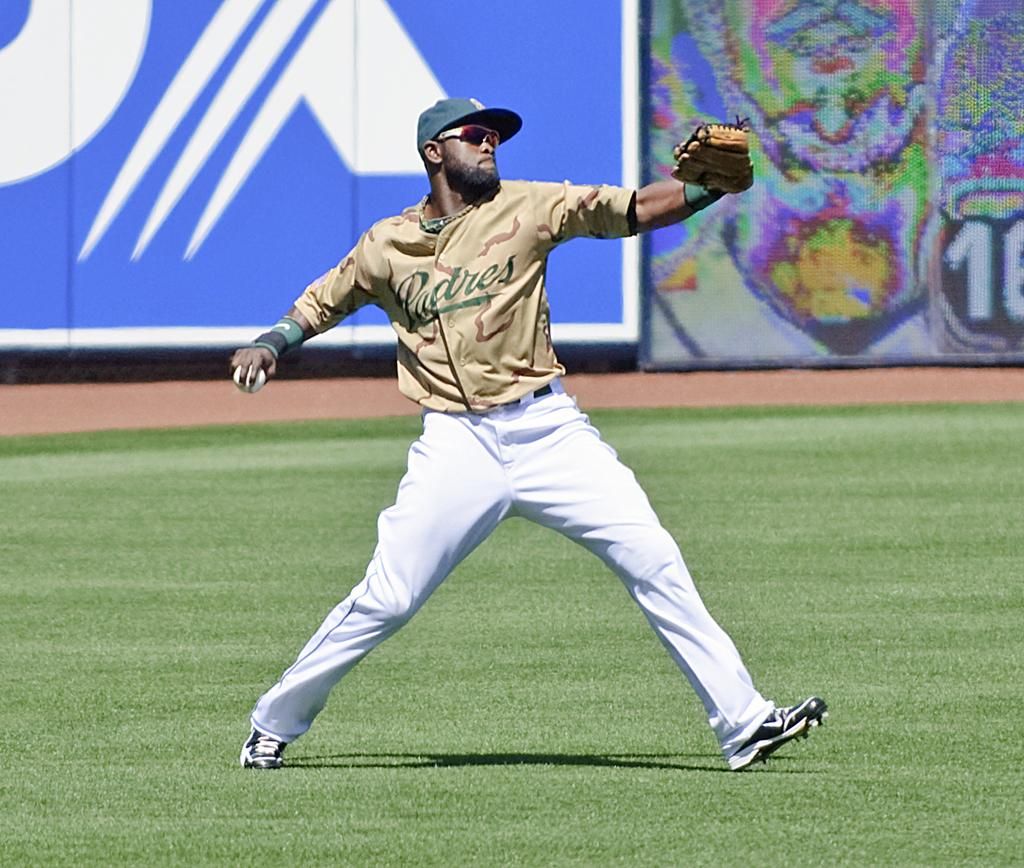<image>
Relay a brief, clear account of the picture shown. Man wearing a Padres jersey about to pitch a ball. 